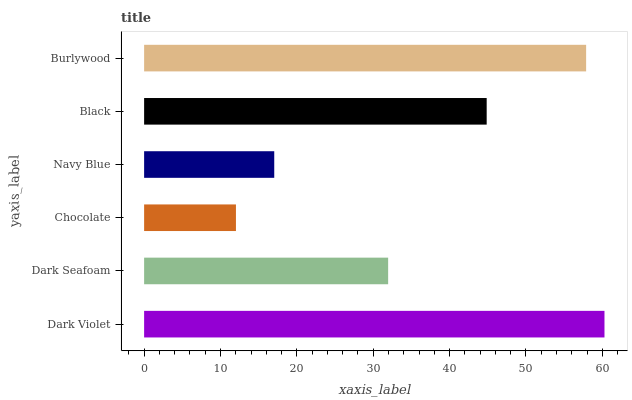Is Chocolate the minimum?
Answer yes or no. Yes. Is Dark Violet the maximum?
Answer yes or no. Yes. Is Dark Seafoam the minimum?
Answer yes or no. No. Is Dark Seafoam the maximum?
Answer yes or no. No. Is Dark Violet greater than Dark Seafoam?
Answer yes or no. Yes. Is Dark Seafoam less than Dark Violet?
Answer yes or no. Yes. Is Dark Seafoam greater than Dark Violet?
Answer yes or no. No. Is Dark Violet less than Dark Seafoam?
Answer yes or no. No. Is Black the high median?
Answer yes or no. Yes. Is Dark Seafoam the low median?
Answer yes or no. Yes. Is Navy Blue the high median?
Answer yes or no. No. Is Navy Blue the low median?
Answer yes or no. No. 